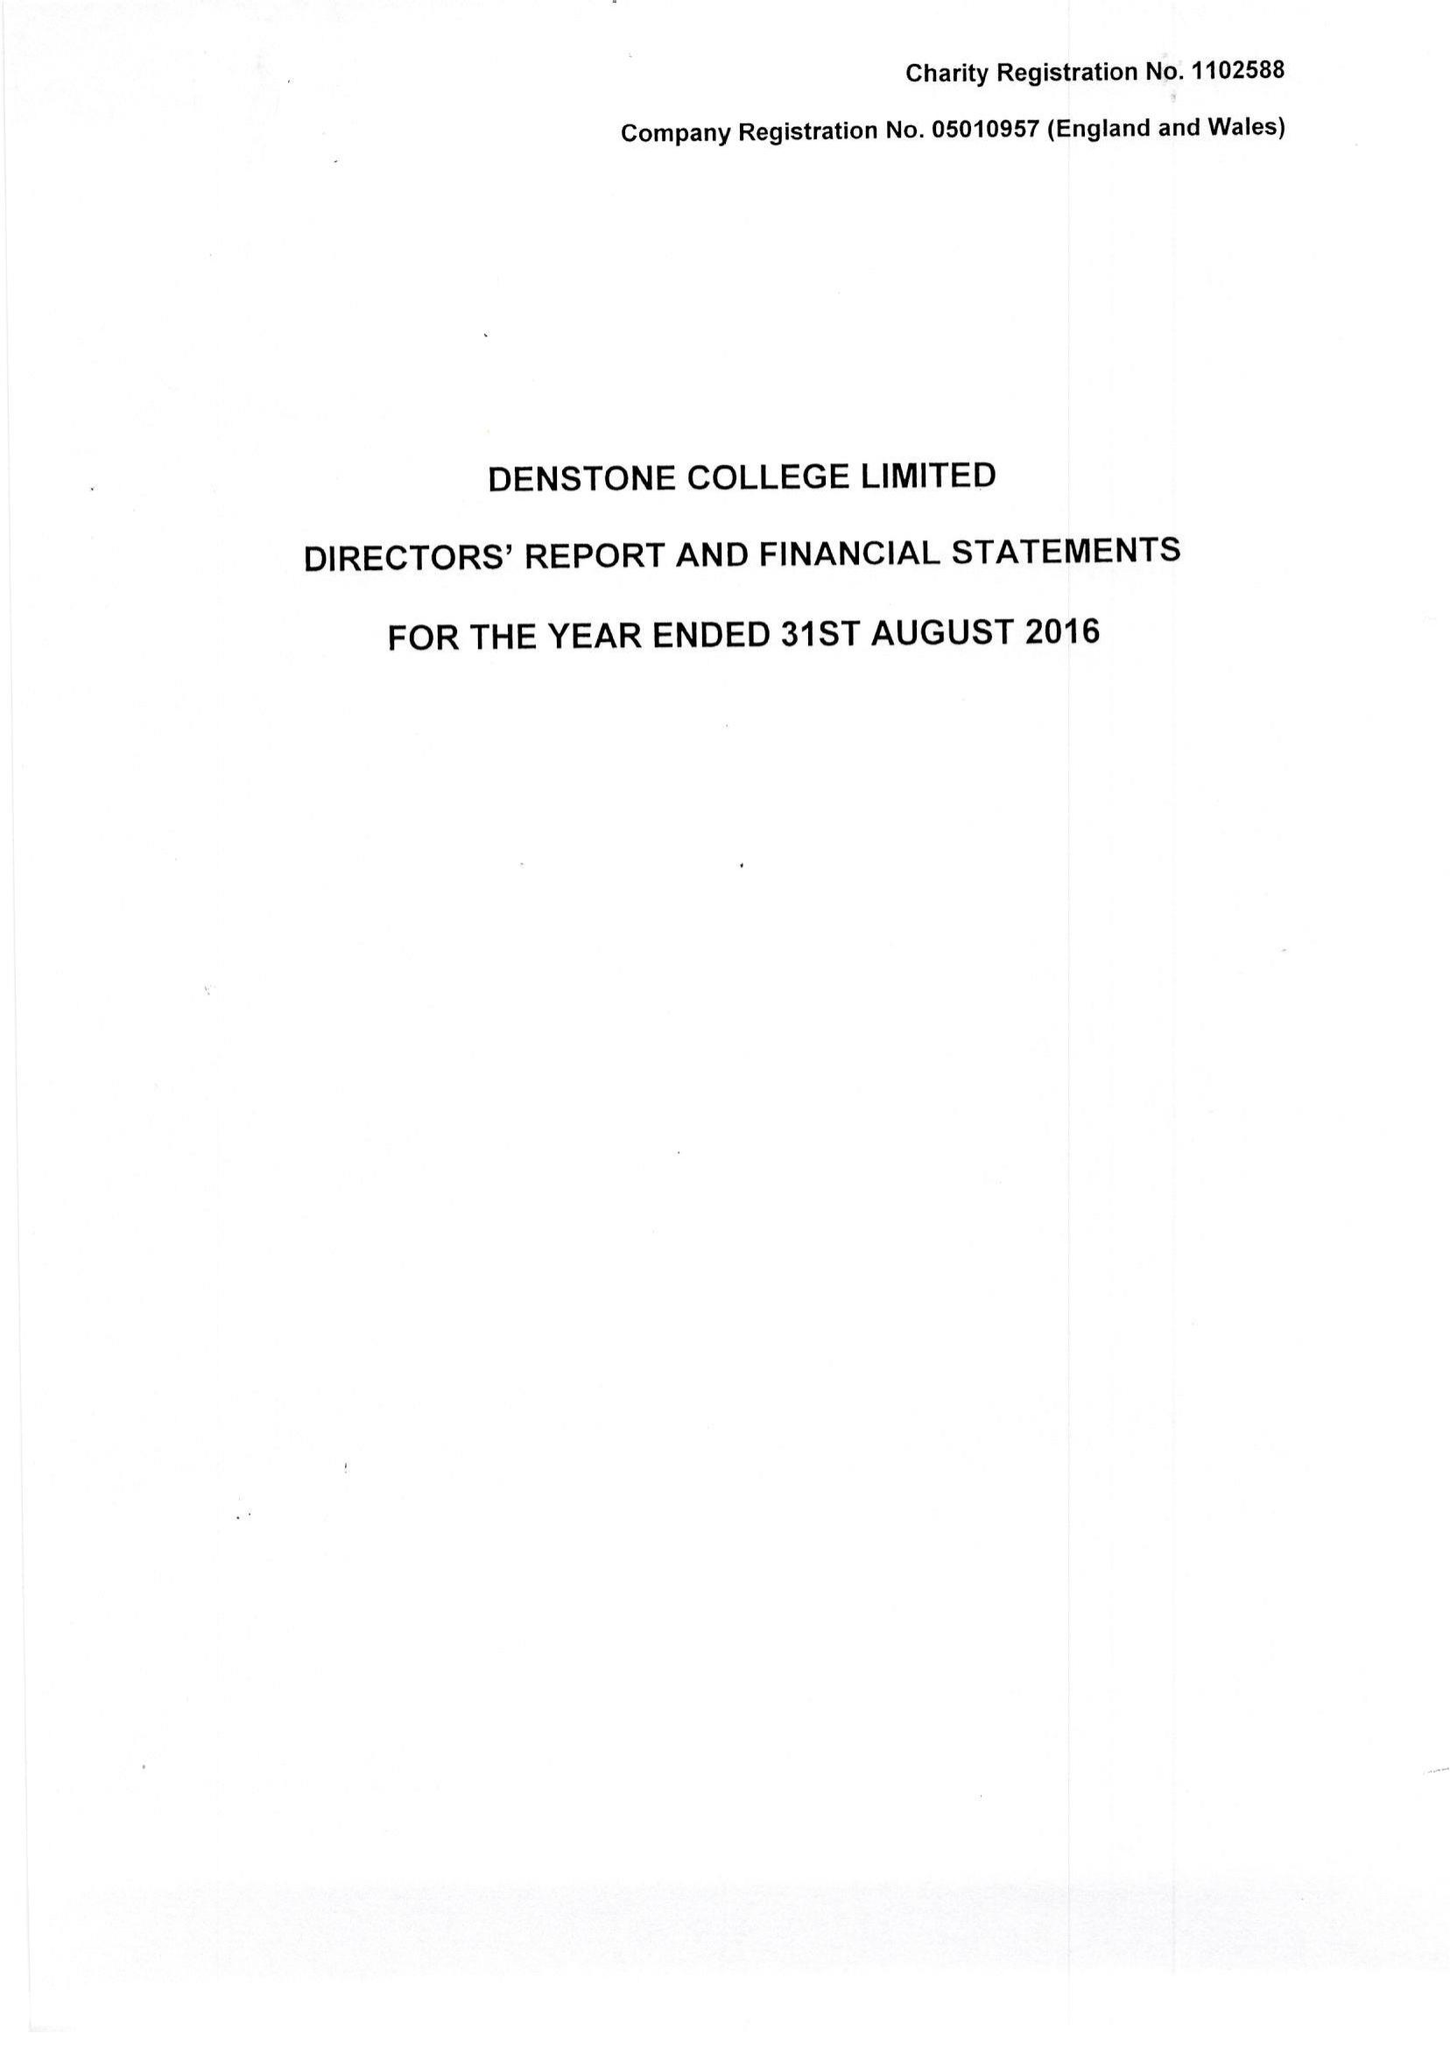What is the value for the address__postcode?
Answer the question using a single word or phrase. ST14 5HN 